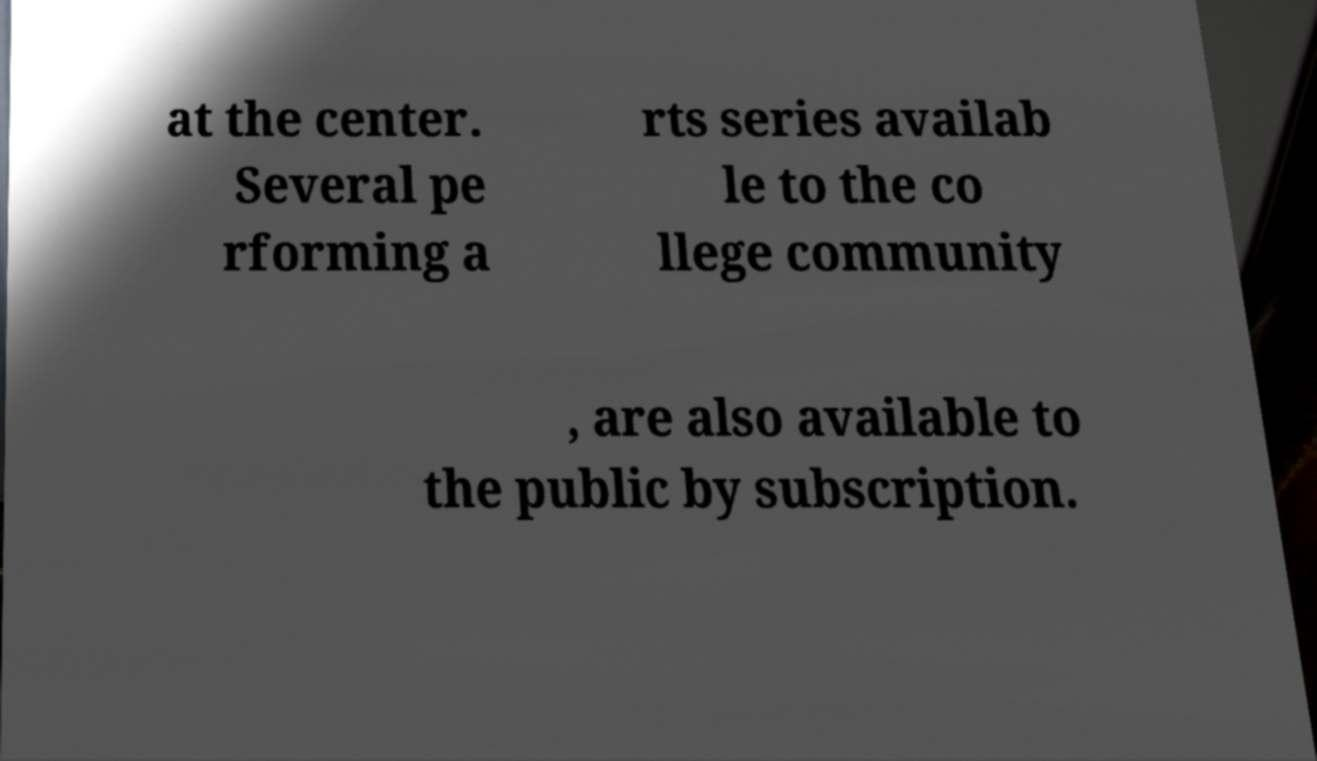For documentation purposes, I need the text within this image transcribed. Could you provide that? at the center. Several pe rforming a rts series availab le to the co llege community , are also available to the public by subscription. 